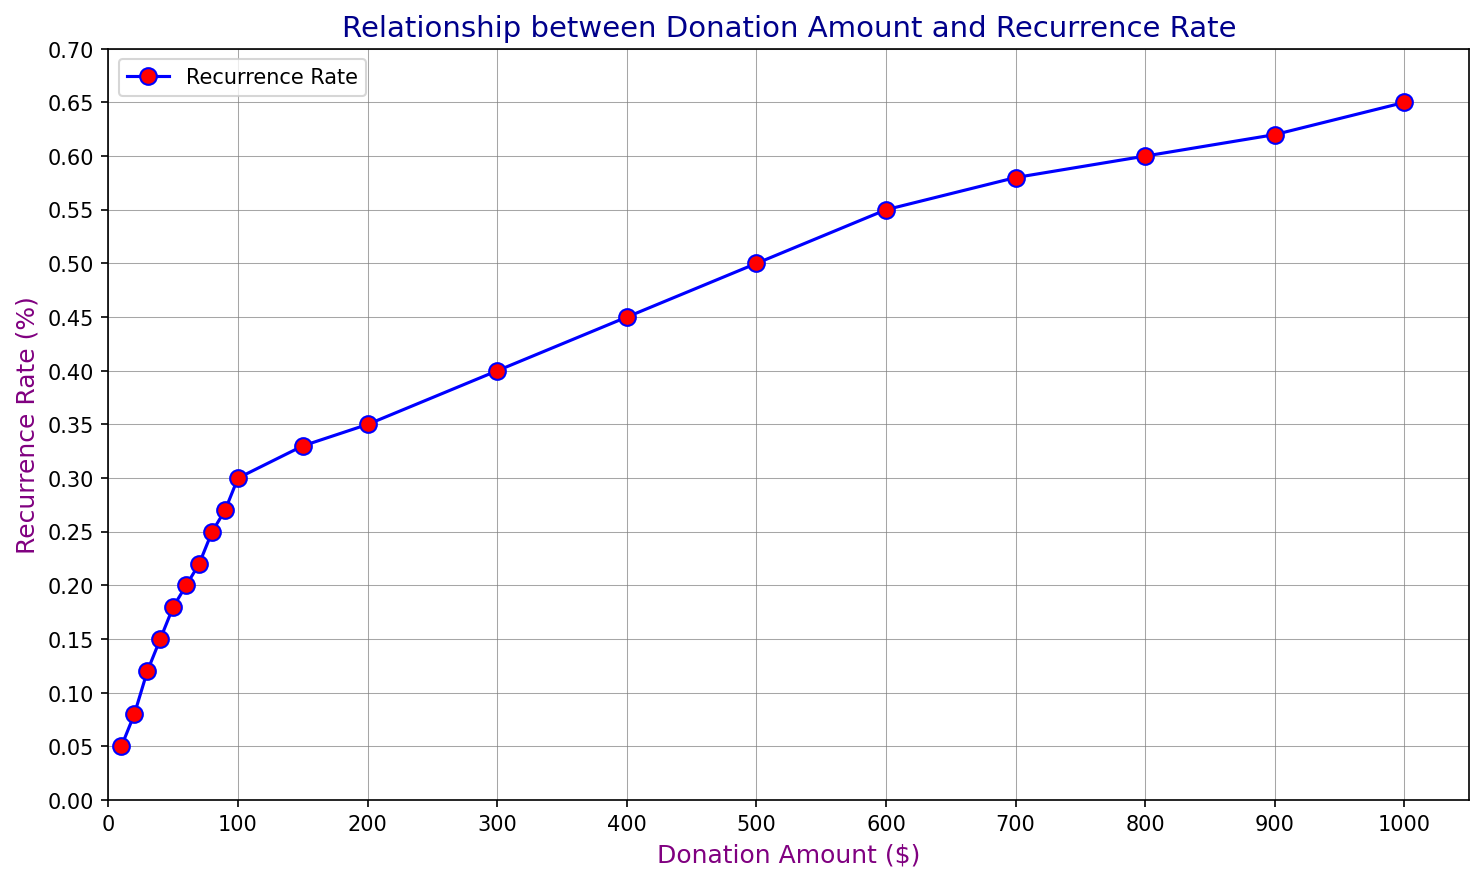What is the highest recurrence rate observed in the plot? The highest recurrence rate can be identified by looking for the maximum value on the y-axis in the plot. The curve peaks at a recurrence rate of 0.65.
Answer: 0.65 What is the donation amount when the recurrence rate reaches 0.30? To find this, locate the point on the curve where the y-value (recurrence rate) is 0.30 and then look directly down to see the corresponding x-value (donation amount), which is 100.
Answer: 100 Which donation amount shows a recurrence rate of 0.45? To determine this, locate the point on the curve where the recurrence rate (y-value) is 0.45. Then trace directly downwards to see the donation amount (x-value), which is 400.
Answer: 400 What is the difference in recurrence rate between a $200 donation and a $700 donation? First, find the recurrence rates for $200 and $700 donations, which are 0.35 and 0.58, respectively. Then, calculate the difference: 0.58 - 0.35 = 0.23.
Answer: 0.23 Compare the recurrence rates for donations of $50 and $500. Which is higher? Look at the recurrence rates corresponding to $50 and $500 donations. The rates are 0.18 for $50 and 0.50 for $500. The rate for $500 is higher.
Answer: $500 At what donation amount does the recurrence rate exceed 0.50 for the first time? Identify the point where the curve first crosses the 0.50 line on the y-axis, which is at a donation amount of 500.
Answer: 500 Which three donation amounts have the lowest recurrence rates, and what are their values? Look for the points with the smallest y-values. The lowest recurrence rates are at donation amounts $10, $20, and $30, with corresponding recurrence rates of 0.05, 0.08, and 0.12, respectively.
Answer: $10, $20, $30 What is the average recurrence rate for donation amounts of $100, $200, and $300? First, identify the recurrence rates for these donations: 0.30, 0.35, and 0.40. Then, calculate the average: (0.30 + 0.35 + 0.40) / 3 = 0.35.
Answer: 0.35 Compare the growth in recurrence rate between the increments of $50 to $100 and $500 to $1000. Which increment shows a greater increase? For $50 to $100, the rates are 0.18 and 0.30, so the increase is 0.30 - 0.18 = 0.12. For $500 to $1000, the rates are 0.50 and 0.65, leading to an increase of 0.65 - 0.50 = 0.15. The second increment shows a greater increase.
Answer: $500 to $1000 At what donation amount does the recurrence rate reach 0.60? Identify the point on the curve where the y-value is 0.60 and then trace down to the corresponding x-value, which is 800.
Answer: 800 